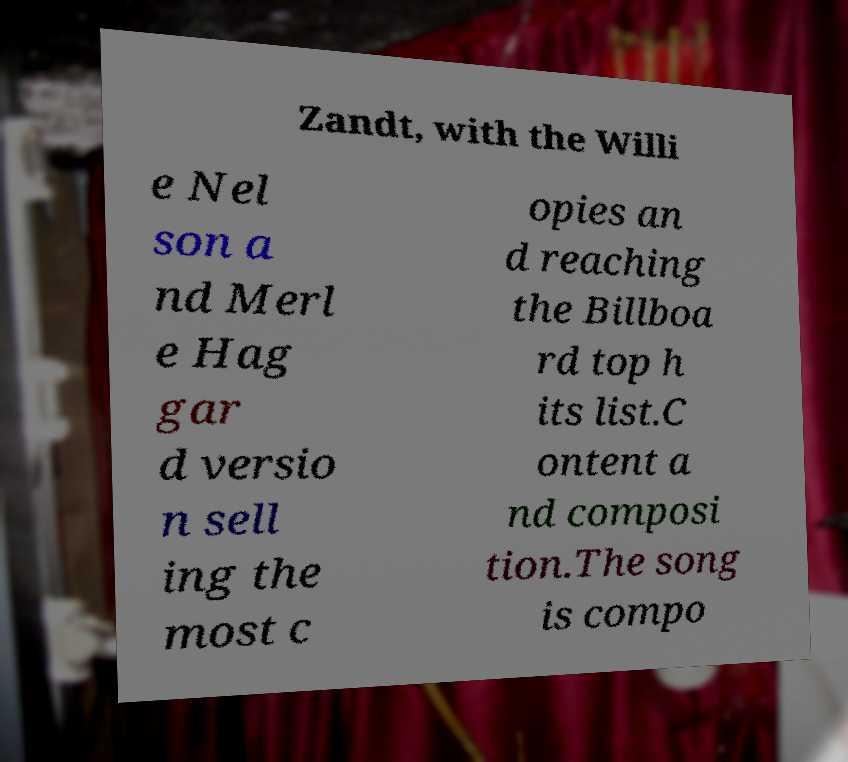Could you assist in decoding the text presented in this image and type it out clearly? Zandt, with the Willi e Nel son a nd Merl e Hag gar d versio n sell ing the most c opies an d reaching the Billboa rd top h its list.C ontent a nd composi tion.The song is compo 